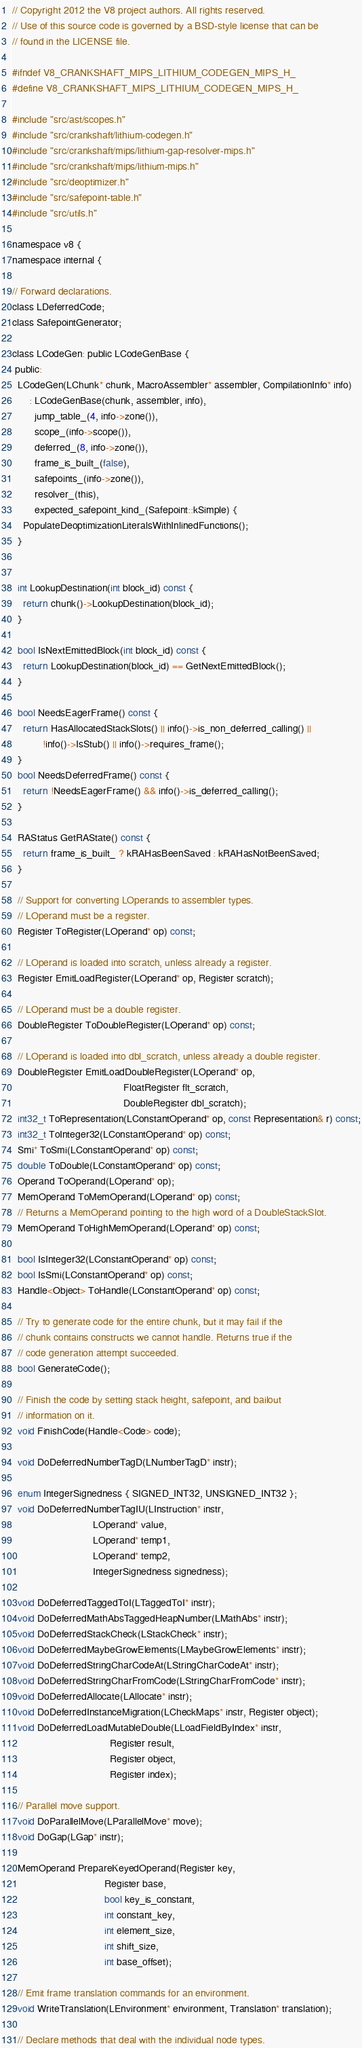Convert code to text. <code><loc_0><loc_0><loc_500><loc_500><_C_>// Copyright 2012 the V8 project authors. All rights reserved.
// Use of this source code is governed by a BSD-style license that can be
// found in the LICENSE file.

#ifndef V8_CRANKSHAFT_MIPS_LITHIUM_CODEGEN_MIPS_H_
#define V8_CRANKSHAFT_MIPS_LITHIUM_CODEGEN_MIPS_H_

#include "src/ast/scopes.h"
#include "src/crankshaft/lithium-codegen.h"
#include "src/crankshaft/mips/lithium-gap-resolver-mips.h"
#include "src/crankshaft/mips/lithium-mips.h"
#include "src/deoptimizer.h"
#include "src/safepoint-table.h"
#include "src/utils.h"

namespace v8 {
namespace internal {

// Forward declarations.
class LDeferredCode;
class SafepointGenerator;

class LCodeGen: public LCodeGenBase {
 public:
  LCodeGen(LChunk* chunk, MacroAssembler* assembler, CompilationInfo* info)
      : LCodeGenBase(chunk, assembler, info),
        jump_table_(4, info->zone()),
        scope_(info->scope()),
        deferred_(8, info->zone()),
        frame_is_built_(false),
        safepoints_(info->zone()),
        resolver_(this),
        expected_safepoint_kind_(Safepoint::kSimple) {
    PopulateDeoptimizationLiteralsWithInlinedFunctions();
  }


  int LookupDestination(int block_id) const {
    return chunk()->LookupDestination(block_id);
  }

  bool IsNextEmittedBlock(int block_id) const {
    return LookupDestination(block_id) == GetNextEmittedBlock();
  }

  bool NeedsEagerFrame() const {
    return HasAllocatedStackSlots() || info()->is_non_deferred_calling() ||
           !info()->IsStub() || info()->requires_frame();
  }
  bool NeedsDeferredFrame() const {
    return !NeedsEagerFrame() && info()->is_deferred_calling();
  }

  RAStatus GetRAState() const {
    return frame_is_built_ ? kRAHasBeenSaved : kRAHasNotBeenSaved;
  }

  // Support for converting LOperands to assembler types.
  // LOperand must be a register.
  Register ToRegister(LOperand* op) const;

  // LOperand is loaded into scratch, unless already a register.
  Register EmitLoadRegister(LOperand* op, Register scratch);

  // LOperand must be a double register.
  DoubleRegister ToDoubleRegister(LOperand* op) const;

  // LOperand is loaded into dbl_scratch, unless already a double register.
  DoubleRegister EmitLoadDoubleRegister(LOperand* op,
                                        FloatRegister flt_scratch,
                                        DoubleRegister dbl_scratch);
  int32_t ToRepresentation(LConstantOperand* op, const Representation& r) const;
  int32_t ToInteger32(LConstantOperand* op) const;
  Smi* ToSmi(LConstantOperand* op) const;
  double ToDouble(LConstantOperand* op) const;
  Operand ToOperand(LOperand* op);
  MemOperand ToMemOperand(LOperand* op) const;
  // Returns a MemOperand pointing to the high word of a DoubleStackSlot.
  MemOperand ToHighMemOperand(LOperand* op) const;

  bool IsInteger32(LConstantOperand* op) const;
  bool IsSmi(LConstantOperand* op) const;
  Handle<Object> ToHandle(LConstantOperand* op) const;

  // Try to generate code for the entire chunk, but it may fail if the
  // chunk contains constructs we cannot handle. Returns true if the
  // code generation attempt succeeded.
  bool GenerateCode();

  // Finish the code by setting stack height, safepoint, and bailout
  // information on it.
  void FinishCode(Handle<Code> code);

  void DoDeferredNumberTagD(LNumberTagD* instr);

  enum IntegerSignedness { SIGNED_INT32, UNSIGNED_INT32 };
  void DoDeferredNumberTagIU(LInstruction* instr,
                             LOperand* value,
                             LOperand* temp1,
                             LOperand* temp2,
                             IntegerSignedness signedness);

  void DoDeferredTaggedToI(LTaggedToI* instr);
  void DoDeferredMathAbsTaggedHeapNumber(LMathAbs* instr);
  void DoDeferredStackCheck(LStackCheck* instr);
  void DoDeferredMaybeGrowElements(LMaybeGrowElements* instr);
  void DoDeferredStringCharCodeAt(LStringCharCodeAt* instr);
  void DoDeferredStringCharFromCode(LStringCharFromCode* instr);
  void DoDeferredAllocate(LAllocate* instr);
  void DoDeferredInstanceMigration(LCheckMaps* instr, Register object);
  void DoDeferredLoadMutableDouble(LLoadFieldByIndex* instr,
                                   Register result,
                                   Register object,
                                   Register index);

  // Parallel move support.
  void DoParallelMove(LParallelMove* move);
  void DoGap(LGap* instr);

  MemOperand PrepareKeyedOperand(Register key,
                                 Register base,
                                 bool key_is_constant,
                                 int constant_key,
                                 int element_size,
                                 int shift_size,
                                 int base_offset);

  // Emit frame translation commands for an environment.
  void WriteTranslation(LEnvironment* environment, Translation* translation);

  // Declare methods that deal with the individual node types.</code> 